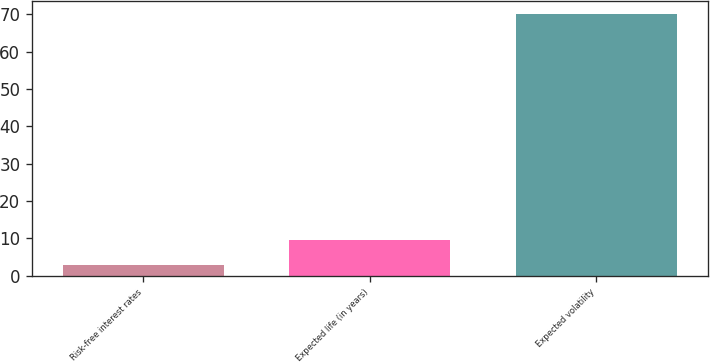<chart> <loc_0><loc_0><loc_500><loc_500><bar_chart><fcel>Risk-free interest rates<fcel>Expected life (in years)<fcel>Expected volatility<nl><fcel>2.9<fcel>9.61<fcel>70<nl></chart> 